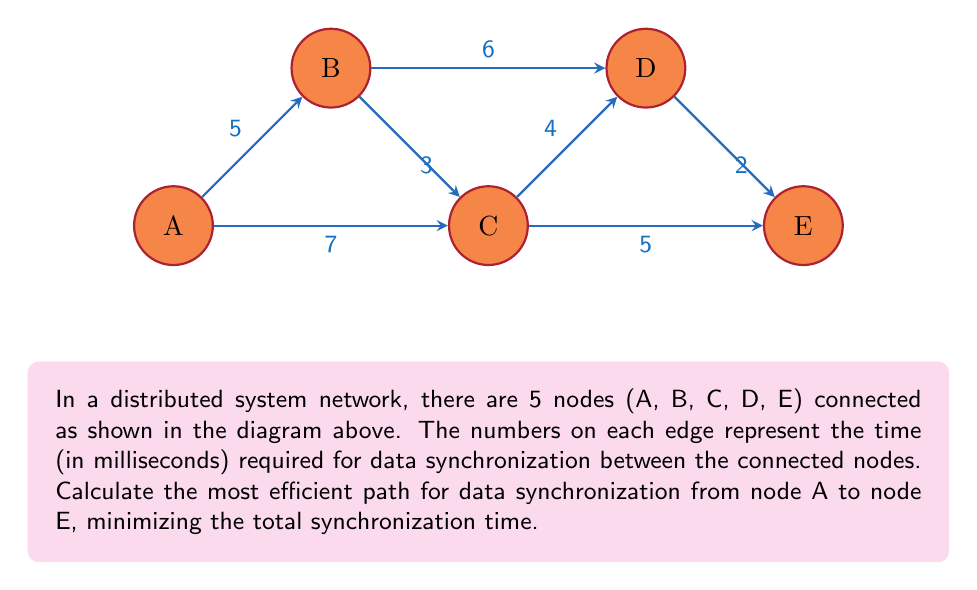Give your solution to this math problem. To find the most efficient path for data synchronization from node A to node E, we need to use Dijkstra's algorithm, which is commonly used to find the shortest path in a weighted graph. Let's follow the steps:

1) Initialize:
   - Set distance to A as 0
   - Set distances to all other nodes as infinity
   - Set all nodes as unvisited

2) Start from node A:
   - Update distances to neighbors:
     B: min(∞, 0 + 5) = 5
     C: min(∞, 0 + 7) = 7

3) Select the unvisited node with the smallest distance (B):
   - Update distances to neighbors:
     C: min(7, 5 + 3) = 7 (no change)
     D: min(∞, 5 + 6) = 11

4) Select the next unvisited node with the smallest distance (C):
   - Update distances to neighbors:
     D: min(11, 7 + 4) = 11 (no change)
     E: min(∞, 7 + 5) = 12

5) Select the next unvisited node with the smallest distance (D):
   - Update distances to neighbors:
     E: min(12, 11 + 2) = 11

6) The algorithm terminates as we've reached node E.

The most efficient path is A → C → E, with a total synchronization time of 12 ms.

To verify:
A → C: 7 ms
C → E: 5 ms
Total: 7 + 5 = 12 ms

This path minimizes the total synchronization time between nodes A and E in the given distributed system network.
Answer: A → C → E, 12 ms 